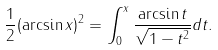Convert formula to latex. <formula><loc_0><loc_0><loc_500><loc_500>\frac { 1 } { 2 } ( \arcsin x ) ^ { 2 } = \int _ { 0 } ^ { x } \frac { \arcsin t } { \sqrt { 1 - t ^ { 2 } } } d t .</formula> 